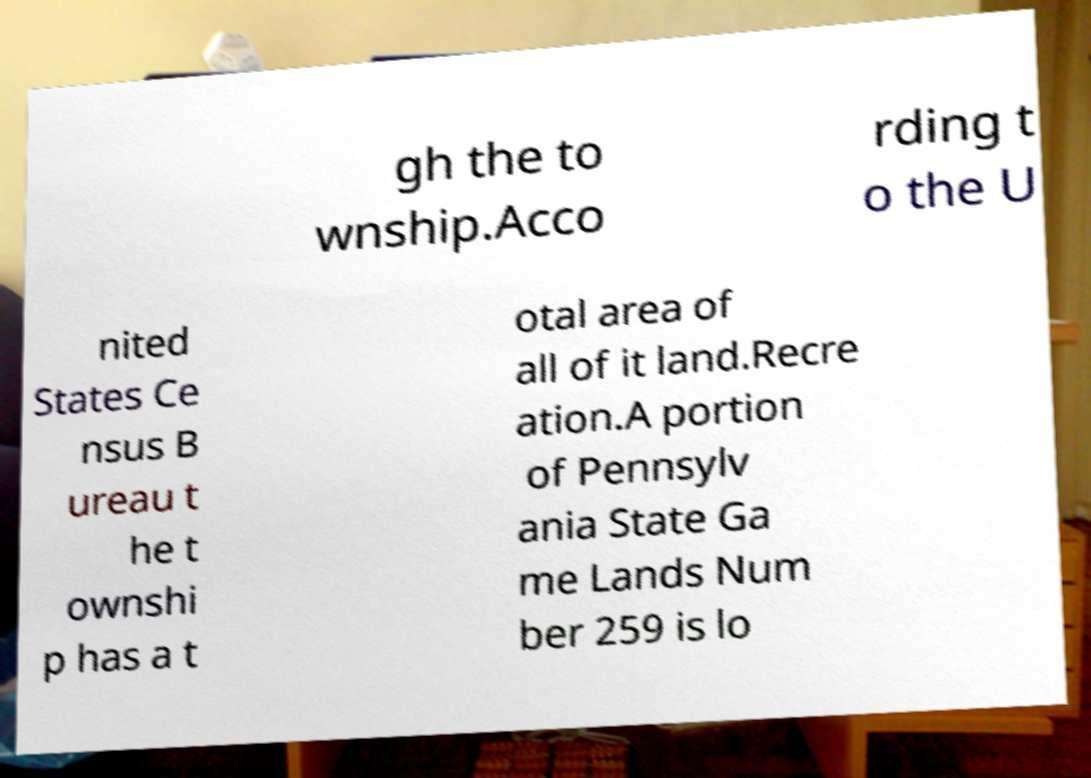Can you accurately transcribe the text from the provided image for me? gh the to wnship.Acco rding t o the U nited States Ce nsus B ureau t he t ownshi p has a t otal area of all of it land.Recre ation.A portion of Pennsylv ania State Ga me Lands Num ber 259 is lo 